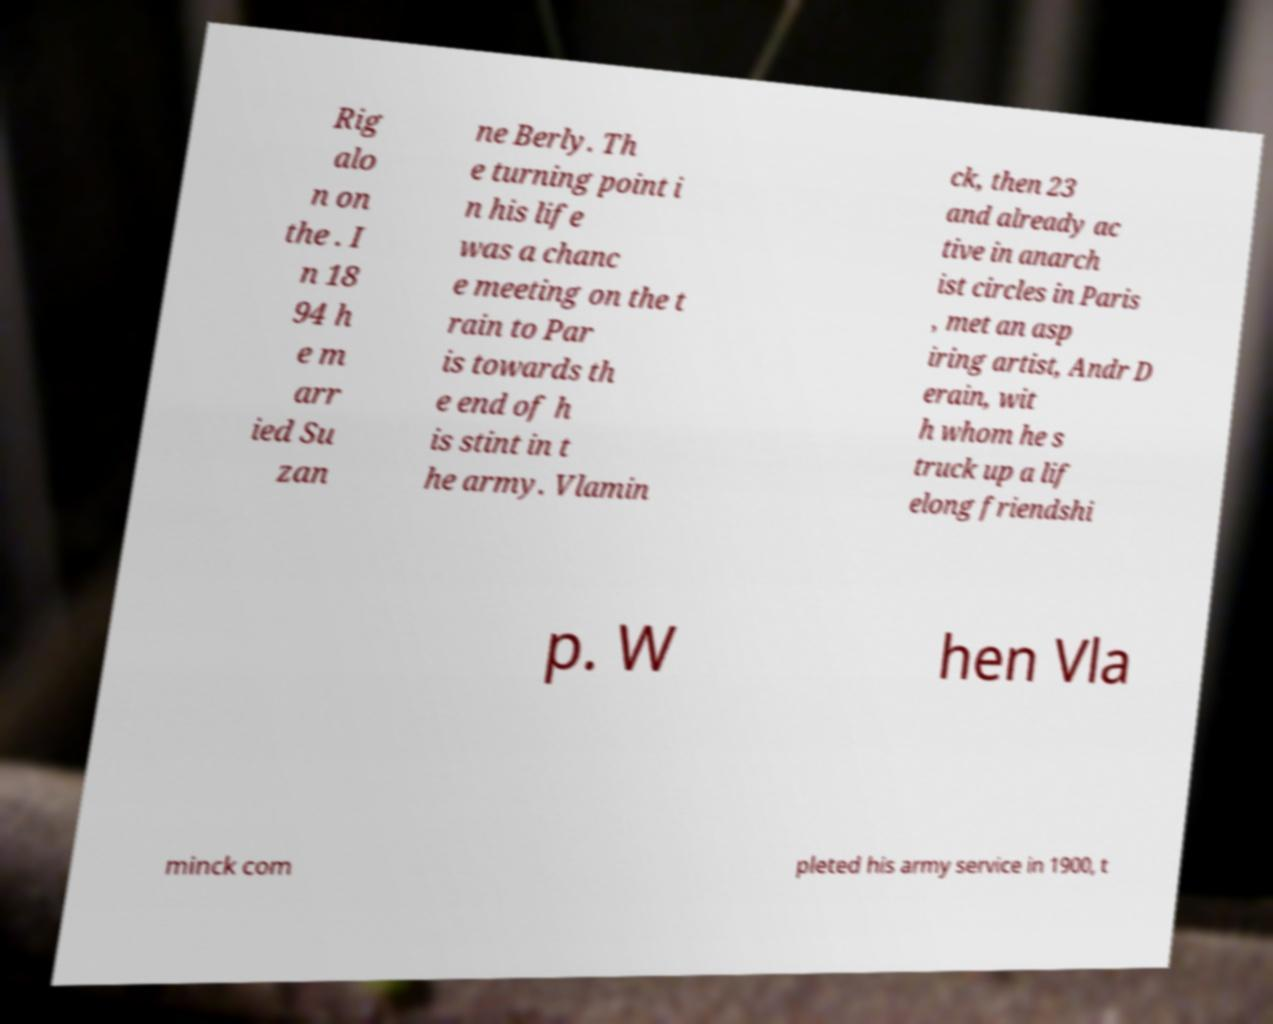I need the written content from this picture converted into text. Can you do that? Rig alo n on the . I n 18 94 h e m arr ied Su zan ne Berly. Th e turning point i n his life was a chanc e meeting on the t rain to Par is towards th e end of h is stint in t he army. Vlamin ck, then 23 and already ac tive in anarch ist circles in Paris , met an asp iring artist, Andr D erain, wit h whom he s truck up a lif elong friendshi p. W hen Vla minck com pleted his army service in 1900, t 